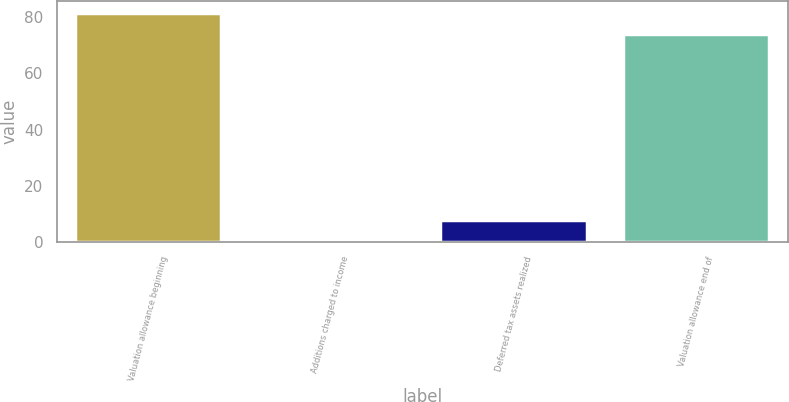<chart> <loc_0><loc_0><loc_500><loc_500><bar_chart><fcel>Valuation allowance beginning<fcel>Additions charged to income<fcel>Deferred tax assets realized<fcel>Valuation allowance end of<nl><fcel>81.57<fcel>0.2<fcel>7.87<fcel>73.9<nl></chart> 